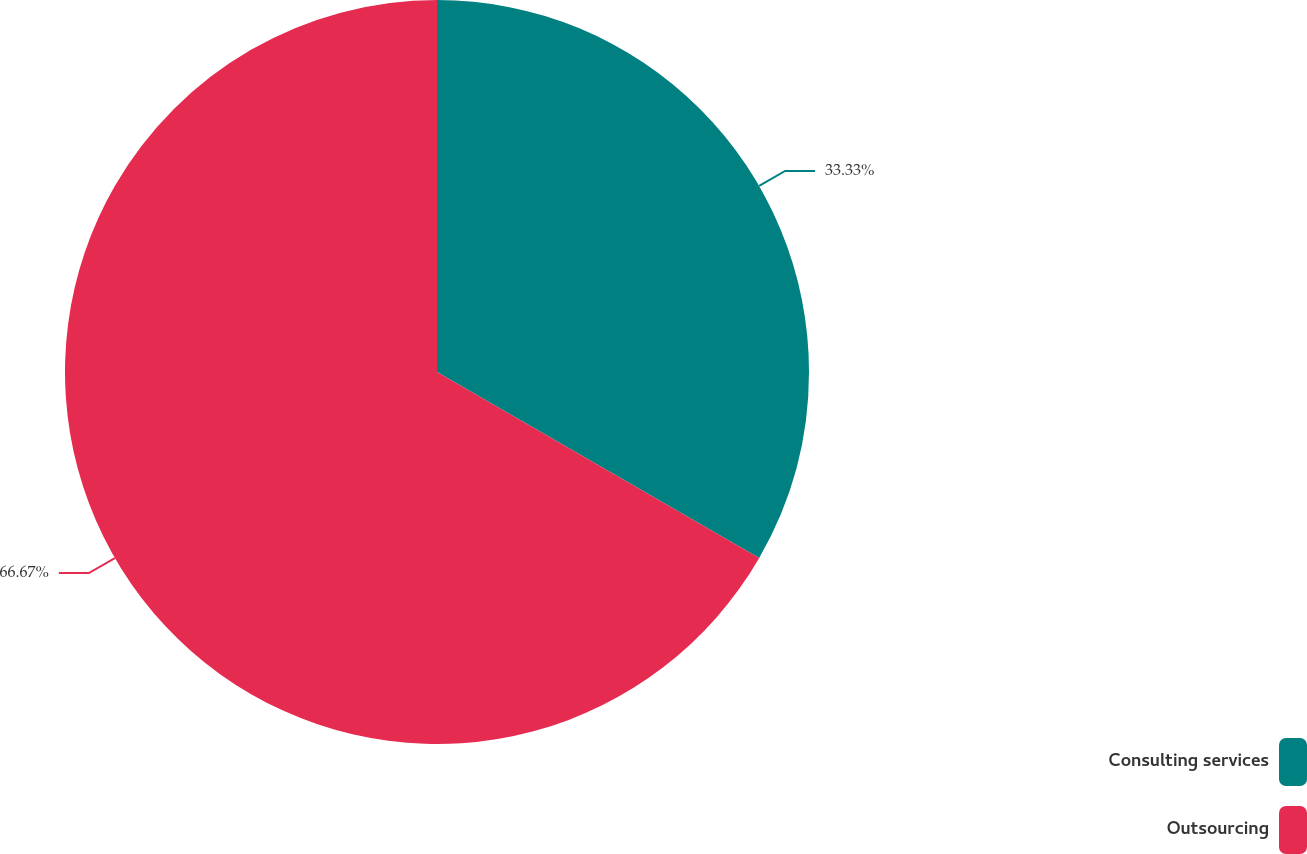<chart> <loc_0><loc_0><loc_500><loc_500><pie_chart><fcel>Consulting services<fcel>Outsourcing<nl><fcel>33.33%<fcel>66.67%<nl></chart> 